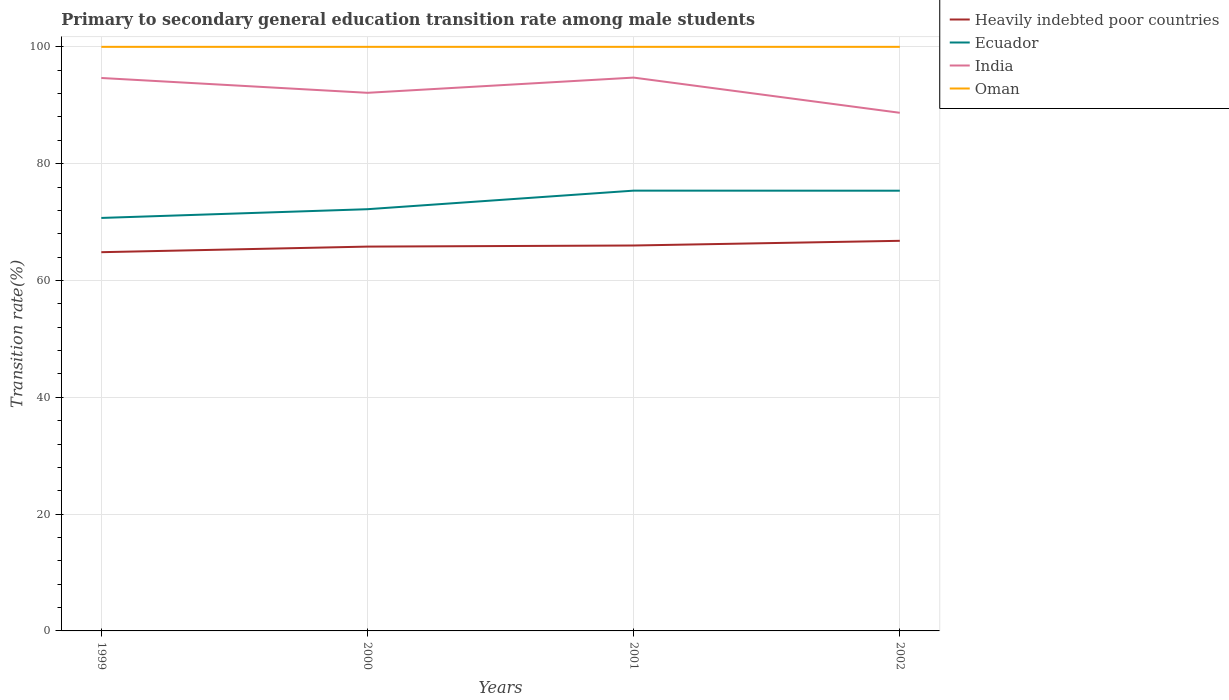How many different coloured lines are there?
Offer a very short reply. 4. Does the line corresponding to India intersect with the line corresponding to Ecuador?
Offer a terse response. No. Across all years, what is the maximum transition rate in India?
Provide a succinct answer. 88.71. In which year was the transition rate in India maximum?
Offer a terse response. 2002. What is the total transition rate in Heavily indebted poor countries in the graph?
Give a very brief answer. -0.99. What is the difference between the highest and the second highest transition rate in Ecuador?
Ensure brevity in your answer.  4.68. Is the transition rate in India strictly greater than the transition rate in Ecuador over the years?
Ensure brevity in your answer.  No. How many lines are there?
Provide a short and direct response. 4. How many years are there in the graph?
Your answer should be compact. 4. What is the difference between two consecutive major ticks on the Y-axis?
Your response must be concise. 20. Where does the legend appear in the graph?
Offer a very short reply. Top right. How many legend labels are there?
Ensure brevity in your answer.  4. How are the legend labels stacked?
Make the answer very short. Vertical. What is the title of the graph?
Make the answer very short. Primary to secondary general education transition rate among male students. What is the label or title of the X-axis?
Provide a short and direct response. Years. What is the label or title of the Y-axis?
Your answer should be very brief. Transition rate(%). What is the Transition rate(%) in Heavily indebted poor countries in 1999?
Make the answer very short. 64.84. What is the Transition rate(%) of Ecuador in 1999?
Provide a succinct answer. 70.71. What is the Transition rate(%) of India in 1999?
Your answer should be very brief. 94.67. What is the Transition rate(%) of Oman in 1999?
Ensure brevity in your answer.  100. What is the Transition rate(%) of Heavily indebted poor countries in 2000?
Provide a succinct answer. 65.8. What is the Transition rate(%) in Ecuador in 2000?
Offer a very short reply. 72.2. What is the Transition rate(%) in India in 2000?
Keep it short and to the point. 92.13. What is the Transition rate(%) of Oman in 2000?
Offer a very short reply. 100. What is the Transition rate(%) of Heavily indebted poor countries in 2001?
Make the answer very short. 65.99. What is the Transition rate(%) in Ecuador in 2001?
Your response must be concise. 75.38. What is the Transition rate(%) in India in 2001?
Make the answer very short. 94.73. What is the Transition rate(%) of Heavily indebted poor countries in 2002?
Give a very brief answer. 66.79. What is the Transition rate(%) of Ecuador in 2002?
Your answer should be very brief. 75.37. What is the Transition rate(%) of India in 2002?
Your response must be concise. 88.71. Across all years, what is the maximum Transition rate(%) of Heavily indebted poor countries?
Keep it short and to the point. 66.79. Across all years, what is the maximum Transition rate(%) of Ecuador?
Your response must be concise. 75.38. Across all years, what is the maximum Transition rate(%) of India?
Provide a short and direct response. 94.73. Across all years, what is the minimum Transition rate(%) of Heavily indebted poor countries?
Give a very brief answer. 64.84. Across all years, what is the minimum Transition rate(%) in Ecuador?
Give a very brief answer. 70.71. Across all years, what is the minimum Transition rate(%) in India?
Your answer should be very brief. 88.71. Across all years, what is the minimum Transition rate(%) of Oman?
Keep it short and to the point. 100. What is the total Transition rate(%) in Heavily indebted poor countries in the graph?
Provide a short and direct response. 263.42. What is the total Transition rate(%) in Ecuador in the graph?
Your answer should be compact. 293.66. What is the total Transition rate(%) in India in the graph?
Your answer should be very brief. 370.24. What is the difference between the Transition rate(%) in Heavily indebted poor countries in 1999 and that in 2000?
Ensure brevity in your answer.  -0.96. What is the difference between the Transition rate(%) in Ecuador in 1999 and that in 2000?
Give a very brief answer. -1.5. What is the difference between the Transition rate(%) in India in 1999 and that in 2000?
Your answer should be very brief. 2.54. What is the difference between the Transition rate(%) in Oman in 1999 and that in 2000?
Your response must be concise. 0. What is the difference between the Transition rate(%) in Heavily indebted poor countries in 1999 and that in 2001?
Your answer should be very brief. -1.14. What is the difference between the Transition rate(%) of Ecuador in 1999 and that in 2001?
Your answer should be very brief. -4.68. What is the difference between the Transition rate(%) of India in 1999 and that in 2001?
Provide a succinct answer. -0.07. What is the difference between the Transition rate(%) of Heavily indebted poor countries in 1999 and that in 2002?
Give a very brief answer. -1.95. What is the difference between the Transition rate(%) of Ecuador in 1999 and that in 2002?
Your response must be concise. -4.66. What is the difference between the Transition rate(%) in India in 1999 and that in 2002?
Give a very brief answer. 5.96. What is the difference between the Transition rate(%) of Heavily indebted poor countries in 2000 and that in 2001?
Provide a short and direct response. -0.19. What is the difference between the Transition rate(%) in Ecuador in 2000 and that in 2001?
Offer a terse response. -3.18. What is the difference between the Transition rate(%) in India in 2000 and that in 2001?
Your answer should be compact. -2.61. What is the difference between the Transition rate(%) of Oman in 2000 and that in 2001?
Offer a very short reply. 0. What is the difference between the Transition rate(%) of Heavily indebted poor countries in 2000 and that in 2002?
Your answer should be very brief. -0.99. What is the difference between the Transition rate(%) of Ecuador in 2000 and that in 2002?
Offer a terse response. -3.17. What is the difference between the Transition rate(%) in India in 2000 and that in 2002?
Your answer should be compact. 3.42. What is the difference between the Transition rate(%) in Oman in 2000 and that in 2002?
Your response must be concise. 0. What is the difference between the Transition rate(%) in Heavily indebted poor countries in 2001 and that in 2002?
Ensure brevity in your answer.  -0.8. What is the difference between the Transition rate(%) of Ecuador in 2001 and that in 2002?
Give a very brief answer. 0.01. What is the difference between the Transition rate(%) in India in 2001 and that in 2002?
Provide a succinct answer. 6.02. What is the difference between the Transition rate(%) in Heavily indebted poor countries in 1999 and the Transition rate(%) in Ecuador in 2000?
Your answer should be compact. -7.36. What is the difference between the Transition rate(%) in Heavily indebted poor countries in 1999 and the Transition rate(%) in India in 2000?
Make the answer very short. -27.28. What is the difference between the Transition rate(%) in Heavily indebted poor countries in 1999 and the Transition rate(%) in Oman in 2000?
Make the answer very short. -35.16. What is the difference between the Transition rate(%) of Ecuador in 1999 and the Transition rate(%) of India in 2000?
Provide a succinct answer. -21.42. What is the difference between the Transition rate(%) in Ecuador in 1999 and the Transition rate(%) in Oman in 2000?
Your response must be concise. -29.29. What is the difference between the Transition rate(%) of India in 1999 and the Transition rate(%) of Oman in 2000?
Provide a succinct answer. -5.33. What is the difference between the Transition rate(%) in Heavily indebted poor countries in 1999 and the Transition rate(%) in Ecuador in 2001?
Make the answer very short. -10.54. What is the difference between the Transition rate(%) in Heavily indebted poor countries in 1999 and the Transition rate(%) in India in 2001?
Your response must be concise. -29.89. What is the difference between the Transition rate(%) of Heavily indebted poor countries in 1999 and the Transition rate(%) of Oman in 2001?
Your answer should be compact. -35.16. What is the difference between the Transition rate(%) in Ecuador in 1999 and the Transition rate(%) in India in 2001?
Your answer should be compact. -24.03. What is the difference between the Transition rate(%) in Ecuador in 1999 and the Transition rate(%) in Oman in 2001?
Offer a terse response. -29.29. What is the difference between the Transition rate(%) in India in 1999 and the Transition rate(%) in Oman in 2001?
Your response must be concise. -5.33. What is the difference between the Transition rate(%) of Heavily indebted poor countries in 1999 and the Transition rate(%) of Ecuador in 2002?
Your answer should be compact. -10.52. What is the difference between the Transition rate(%) of Heavily indebted poor countries in 1999 and the Transition rate(%) of India in 2002?
Your response must be concise. -23.87. What is the difference between the Transition rate(%) of Heavily indebted poor countries in 1999 and the Transition rate(%) of Oman in 2002?
Give a very brief answer. -35.16. What is the difference between the Transition rate(%) in Ecuador in 1999 and the Transition rate(%) in India in 2002?
Your answer should be compact. -18. What is the difference between the Transition rate(%) in Ecuador in 1999 and the Transition rate(%) in Oman in 2002?
Give a very brief answer. -29.29. What is the difference between the Transition rate(%) in India in 1999 and the Transition rate(%) in Oman in 2002?
Make the answer very short. -5.33. What is the difference between the Transition rate(%) of Heavily indebted poor countries in 2000 and the Transition rate(%) of Ecuador in 2001?
Give a very brief answer. -9.58. What is the difference between the Transition rate(%) in Heavily indebted poor countries in 2000 and the Transition rate(%) in India in 2001?
Offer a terse response. -28.93. What is the difference between the Transition rate(%) of Heavily indebted poor countries in 2000 and the Transition rate(%) of Oman in 2001?
Keep it short and to the point. -34.2. What is the difference between the Transition rate(%) in Ecuador in 2000 and the Transition rate(%) in India in 2001?
Give a very brief answer. -22.53. What is the difference between the Transition rate(%) of Ecuador in 2000 and the Transition rate(%) of Oman in 2001?
Make the answer very short. -27.8. What is the difference between the Transition rate(%) of India in 2000 and the Transition rate(%) of Oman in 2001?
Your answer should be very brief. -7.87. What is the difference between the Transition rate(%) of Heavily indebted poor countries in 2000 and the Transition rate(%) of Ecuador in 2002?
Make the answer very short. -9.57. What is the difference between the Transition rate(%) of Heavily indebted poor countries in 2000 and the Transition rate(%) of India in 2002?
Give a very brief answer. -22.91. What is the difference between the Transition rate(%) of Heavily indebted poor countries in 2000 and the Transition rate(%) of Oman in 2002?
Your answer should be compact. -34.2. What is the difference between the Transition rate(%) of Ecuador in 2000 and the Transition rate(%) of India in 2002?
Give a very brief answer. -16.51. What is the difference between the Transition rate(%) of Ecuador in 2000 and the Transition rate(%) of Oman in 2002?
Make the answer very short. -27.8. What is the difference between the Transition rate(%) in India in 2000 and the Transition rate(%) in Oman in 2002?
Ensure brevity in your answer.  -7.87. What is the difference between the Transition rate(%) of Heavily indebted poor countries in 2001 and the Transition rate(%) of Ecuador in 2002?
Provide a short and direct response. -9.38. What is the difference between the Transition rate(%) of Heavily indebted poor countries in 2001 and the Transition rate(%) of India in 2002?
Your response must be concise. -22.72. What is the difference between the Transition rate(%) in Heavily indebted poor countries in 2001 and the Transition rate(%) in Oman in 2002?
Keep it short and to the point. -34.01. What is the difference between the Transition rate(%) of Ecuador in 2001 and the Transition rate(%) of India in 2002?
Make the answer very short. -13.33. What is the difference between the Transition rate(%) in Ecuador in 2001 and the Transition rate(%) in Oman in 2002?
Make the answer very short. -24.62. What is the difference between the Transition rate(%) of India in 2001 and the Transition rate(%) of Oman in 2002?
Your answer should be compact. -5.27. What is the average Transition rate(%) of Heavily indebted poor countries per year?
Ensure brevity in your answer.  65.86. What is the average Transition rate(%) of Ecuador per year?
Give a very brief answer. 73.41. What is the average Transition rate(%) of India per year?
Offer a terse response. 92.56. In the year 1999, what is the difference between the Transition rate(%) in Heavily indebted poor countries and Transition rate(%) in Ecuador?
Your answer should be very brief. -5.86. In the year 1999, what is the difference between the Transition rate(%) in Heavily indebted poor countries and Transition rate(%) in India?
Your response must be concise. -29.82. In the year 1999, what is the difference between the Transition rate(%) in Heavily indebted poor countries and Transition rate(%) in Oman?
Make the answer very short. -35.16. In the year 1999, what is the difference between the Transition rate(%) of Ecuador and Transition rate(%) of India?
Provide a succinct answer. -23.96. In the year 1999, what is the difference between the Transition rate(%) of Ecuador and Transition rate(%) of Oman?
Give a very brief answer. -29.29. In the year 1999, what is the difference between the Transition rate(%) of India and Transition rate(%) of Oman?
Provide a succinct answer. -5.33. In the year 2000, what is the difference between the Transition rate(%) of Heavily indebted poor countries and Transition rate(%) of Ecuador?
Provide a short and direct response. -6.4. In the year 2000, what is the difference between the Transition rate(%) of Heavily indebted poor countries and Transition rate(%) of India?
Your response must be concise. -26.33. In the year 2000, what is the difference between the Transition rate(%) in Heavily indebted poor countries and Transition rate(%) in Oman?
Keep it short and to the point. -34.2. In the year 2000, what is the difference between the Transition rate(%) in Ecuador and Transition rate(%) in India?
Make the answer very short. -19.93. In the year 2000, what is the difference between the Transition rate(%) of Ecuador and Transition rate(%) of Oman?
Keep it short and to the point. -27.8. In the year 2000, what is the difference between the Transition rate(%) of India and Transition rate(%) of Oman?
Offer a very short reply. -7.87. In the year 2001, what is the difference between the Transition rate(%) in Heavily indebted poor countries and Transition rate(%) in Ecuador?
Give a very brief answer. -9.39. In the year 2001, what is the difference between the Transition rate(%) in Heavily indebted poor countries and Transition rate(%) in India?
Give a very brief answer. -28.75. In the year 2001, what is the difference between the Transition rate(%) in Heavily indebted poor countries and Transition rate(%) in Oman?
Provide a short and direct response. -34.01. In the year 2001, what is the difference between the Transition rate(%) of Ecuador and Transition rate(%) of India?
Your answer should be compact. -19.35. In the year 2001, what is the difference between the Transition rate(%) of Ecuador and Transition rate(%) of Oman?
Offer a very short reply. -24.62. In the year 2001, what is the difference between the Transition rate(%) in India and Transition rate(%) in Oman?
Your response must be concise. -5.27. In the year 2002, what is the difference between the Transition rate(%) of Heavily indebted poor countries and Transition rate(%) of Ecuador?
Provide a short and direct response. -8.58. In the year 2002, what is the difference between the Transition rate(%) in Heavily indebted poor countries and Transition rate(%) in India?
Keep it short and to the point. -21.92. In the year 2002, what is the difference between the Transition rate(%) of Heavily indebted poor countries and Transition rate(%) of Oman?
Give a very brief answer. -33.21. In the year 2002, what is the difference between the Transition rate(%) of Ecuador and Transition rate(%) of India?
Provide a short and direct response. -13.34. In the year 2002, what is the difference between the Transition rate(%) of Ecuador and Transition rate(%) of Oman?
Provide a short and direct response. -24.63. In the year 2002, what is the difference between the Transition rate(%) in India and Transition rate(%) in Oman?
Keep it short and to the point. -11.29. What is the ratio of the Transition rate(%) in Heavily indebted poor countries in 1999 to that in 2000?
Offer a very short reply. 0.99. What is the ratio of the Transition rate(%) in Ecuador in 1999 to that in 2000?
Provide a short and direct response. 0.98. What is the ratio of the Transition rate(%) in India in 1999 to that in 2000?
Give a very brief answer. 1.03. What is the ratio of the Transition rate(%) in Oman in 1999 to that in 2000?
Your response must be concise. 1. What is the ratio of the Transition rate(%) of Heavily indebted poor countries in 1999 to that in 2001?
Provide a short and direct response. 0.98. What is the ratio of the Transition rate(%) in Ecuador in 1999 to that in 2001?
Your answer should be compact. 0.94. What is the ratio of the Transition rate(%) of Oman in 1999 to that in 2001?
Your answer should be very brief. 1. What is the ratio of the Transition rate(%) of Heavily indebted poor countries in 1999 to that in 2002?
Ensure brevity in your answer.  0.97. What is the ratio of the Transition rate(%) in Ecuador in 1999 to that in 2002?
Give a very brief answer. 0.94. What is the ratio of the Transition rate(%) of India in 1999 to that in 2002?
Your answer should be very brief. 1.07. What is the ratio of the Transition rate(%) in Heavily indebted poor countries in 2000 to that in 2001?
Your answer should be compact. 1. What is the ratio of the Transition rate(%) of Ecuador in 2000 to that in 2001?
Ensure brevity in your answer.  0.96. What is the ratio of the Transition rate(%) in India in 2000 to that in 2001?
Offer a terse response. 0.97. What is the ratio of the Transition rate(%) in Oman in 2000 to that in 2001?
Keep it short and to the point. 1. What is the ratio of the Transition rate(%) of Heavily indebted poor countries in 2000 to that in 2002?
Your answer should be very brief. 0.99. What is the ratio of the Transition rate(%) of Ecuador in 2000 to that in 2002?
Provide a short and direct response. 0.96. What is the ratio of the Transition rate(%) in Ecuador in 2001 to that in 2002?
Provide a succinct answer. 1. What is the ratio of the Transition rate(%) in India in 2001 to that in 2002?
Offer a terse response. 1.07. What is the ratio of the Transition rate(%) in Oman in 2001 to that in 2002?
Keep it short and to the point. 1. What is the difference between the highest and the second highest Transition rate(%) in Heavily indebted poor countries?
Provide a succinct answer. 0.8. What is the difference between the highest and the second highest Transition rate(%) of Ecuador?
Give a very brief answer. 0.01. What is the difference between the highest and the second highest Transition rate(%) in India?
Your response must be concise. 0.07. What is the difference between the highest and the second highest Transition rate(%) in Oman?
Ensure brevity in your answer.  0. What is the difference between the highest and the lowest Transition rate(%) of Heavily indebted poor countries?
Keep it short and to the point. 1.95. What is the difference between the highest and the lowest Transition rate(%) in Ecuador?
Give a very brief answer. 4.68. What is the difference between the highest and the lowest Transition rate(%) of India?
Keep it short and to the point. 6.02. What is the difference between the highest and the lowest Transition rate(%) in Oman?
Your answer should be very brief. 0. 